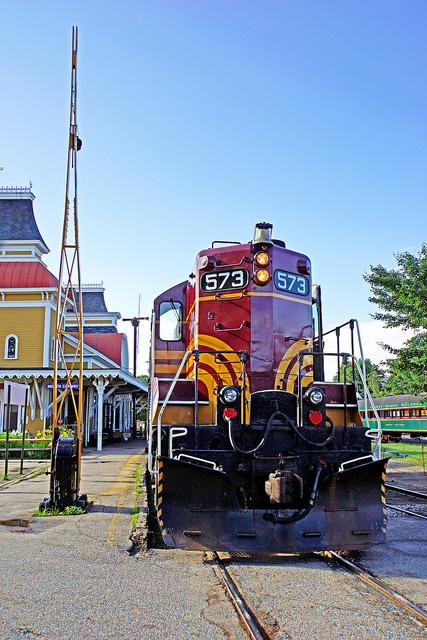<image>What does the sign say? It is uncertain what the sign says. It could say '573', 'stop', or 'go'. What does the sign say? The sign says '573'. 